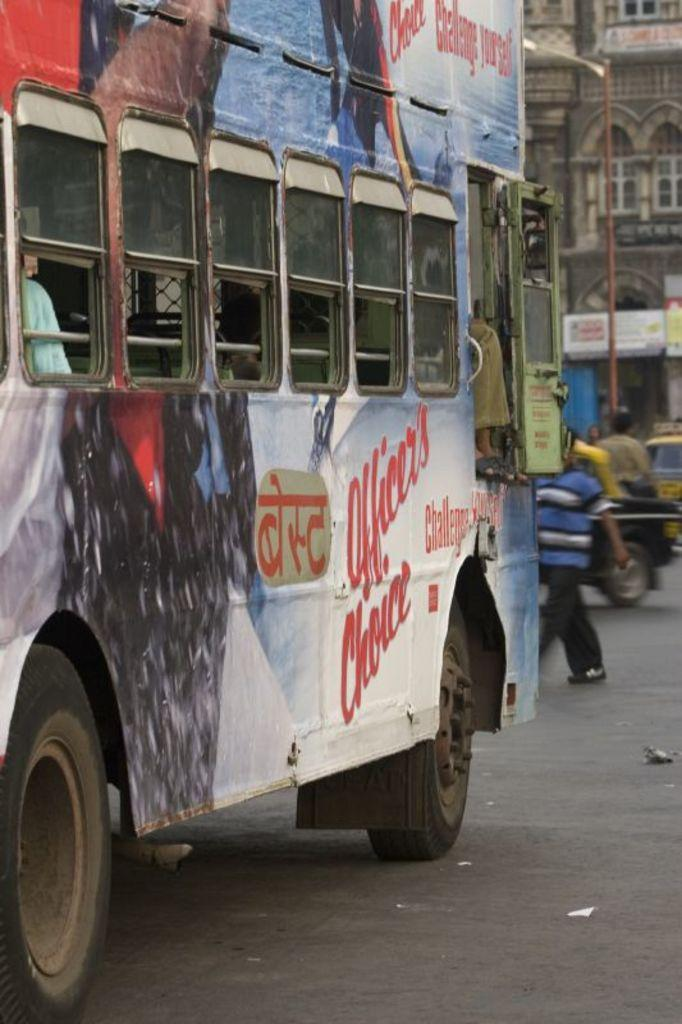What is the main feature of the image? There is a road in the image. What can be seen on the road? There is a bus on the road. What are the characteristics of the bus? The bus has windows. What else can be seen in the background of the image? There is a person walking, a building, and a pole in the background. What type of needle can be seen in the image? There is no needle present in the image. Is the location of the image downtown? The location of the image is not specified as downtown, and there is no information in the image to suggest it is downtown. 